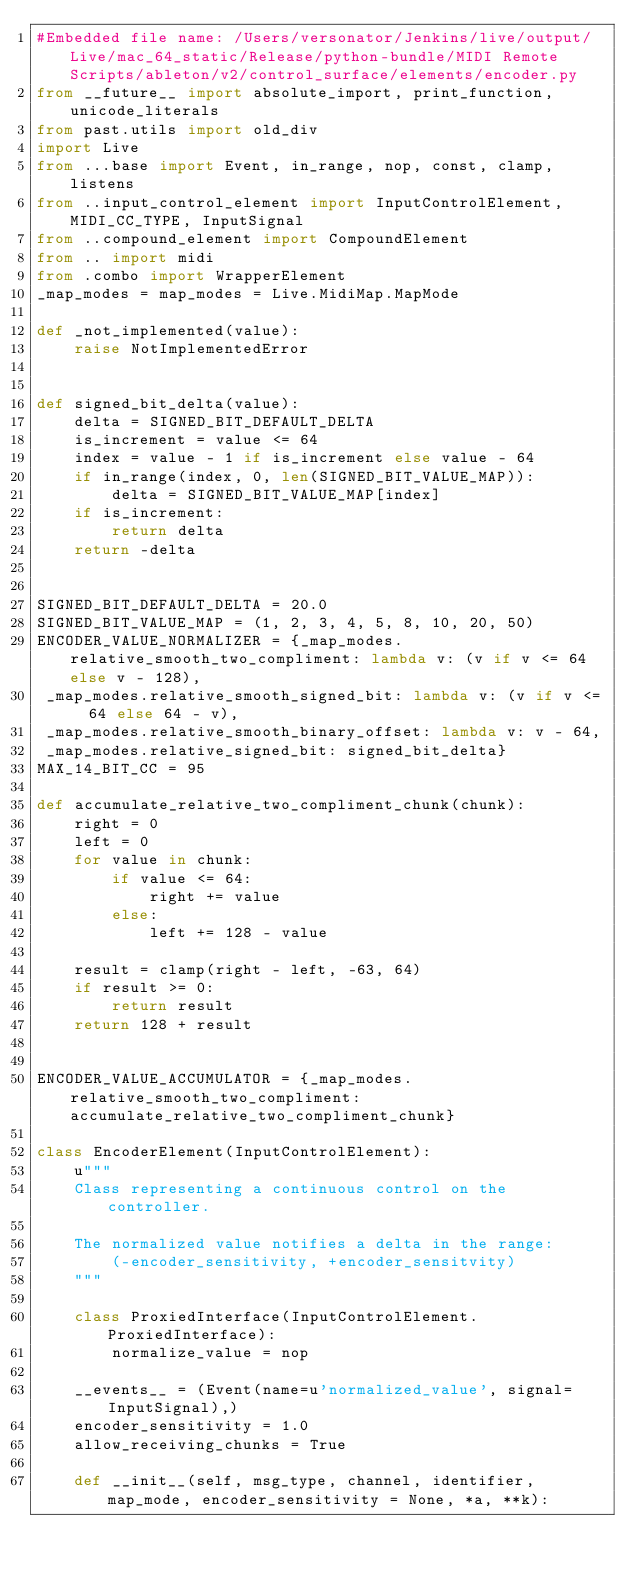<code> <loc_0><loc_0><loc_500><loc_500><_Python_>#Embedded file name: /Users/versonator/Jenkins/live/output/Live/mac_64_static/Release/python-bundle/MIDI Remote Scripts/ableton/v2/control_surface/elements/encoder.py
from __future__ import absolute_import, print_function, unicode_literals
from past.utils import old_div
import Live
from ...base import Event, in_range, nop, const, clamp, listens
from ..input_control_element import InputControlElement, MIDI_CC_TYPE, InputSignal
from ..compound_element import CompoundElement
from .. import midi
from .combo import WrapperElement
_map_modes = map_modes = Live.MidiMap.MapMode

def _not_implemented(value):
    raise NotImplementedError


def signed_bit_delta(value):
    delta = SIGNED_BIT_DEFAULT_DELTA
    is_increment = value <= 64
    index = value - 1 if is_increment else value - 64
    if in_range(index, 0, len(SIGNED_BIT_VALUE_MAP)):
        delta = SIGNED_BIT_VALUE_MAP[index]
    if is_increment:
        return delta
    return -delta


SIGNED_BIT_DEFAULT_DELTA = 20.0
SIGNED_BIT_VALUE_MAP = (1, 2, 3, 4, 5, 8, 10, 20, 50)
ENCODER_VALUE_NORMALIZER = {_map_modes.relative_smooth_two_compliment: lambda v: (v if v <= 64 else v - 128),
 _map_modes.relative_smooth_signed_bit: lambda v: (v if v <= 64 else 64 - v),
 _map_modes.relative_smooth_binary_offset: lambda v: v - 64,
 _map_modes.relative_signed_bit: signed_bit_delta}
MAX_14_BIT_CC = 95

def accumulate_relative_two_compliment_chunk(chunk):
    right = 0
    left = 0
    for value in chunk:
        if value <= 64:
            right += value
        else:
            left += 128 - value

    result = clamp(right - left, -63, 64)
    if result >= 0:
        return result
    return 128 + result


ENCODER_VALUE_ACCUMULATOR = {_map_modes.relative_smooth_two_compliment: accumulate_relative_two_compliment_chunk}

class EncoderElement(InputControlElement):
    u"""
    Class representing a continuous control on the controller.
    
    The normalized value notifies a delta in the range:
        (-encoder_sensitivity, +encoder_sensitvity)
    """

    class ProxiedInterface(InputControlElement.ProxiedInterface):
        normalize_value = nop

    __events__ = (Event(name=u'normalized_value', signal=InputSignal),)
    encoder_sensitivity = 1.0
    allow_receiving_chunks = True

    def __init__(self, msg_type, channel, identifier, map_mode, encoder_sensitivity = None, *a, **k):</code> 